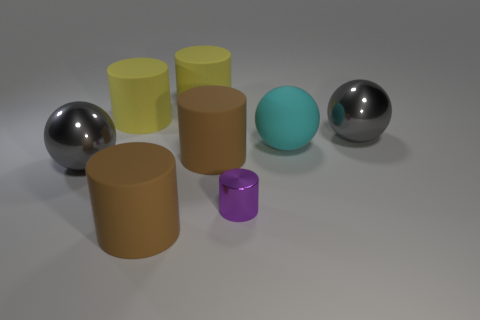Subtract all large brown cylinders. How many cylinders are left? 3 Subtract 1 spheres. How many spheres are left? 2 Add 2 purple metallic things. How many objects exist? 10 Subtract all purple cylinders. How many cylinders are left? 4 Subtract all balls. Subtract all large cyan things. How many objects are left? 4 Add 6 gray shiny balls. How many gray shiny balls are left? 8 Add 6 yellow cylinders. How many yellow cylinders exist? 8 Subtract 0 purple balls. How many objects are left? 8 Subtract all cylinders. How many objects are left? 3 Subtract all gray cylinders. Subtract all red balls. How many cylinders are left? 5 